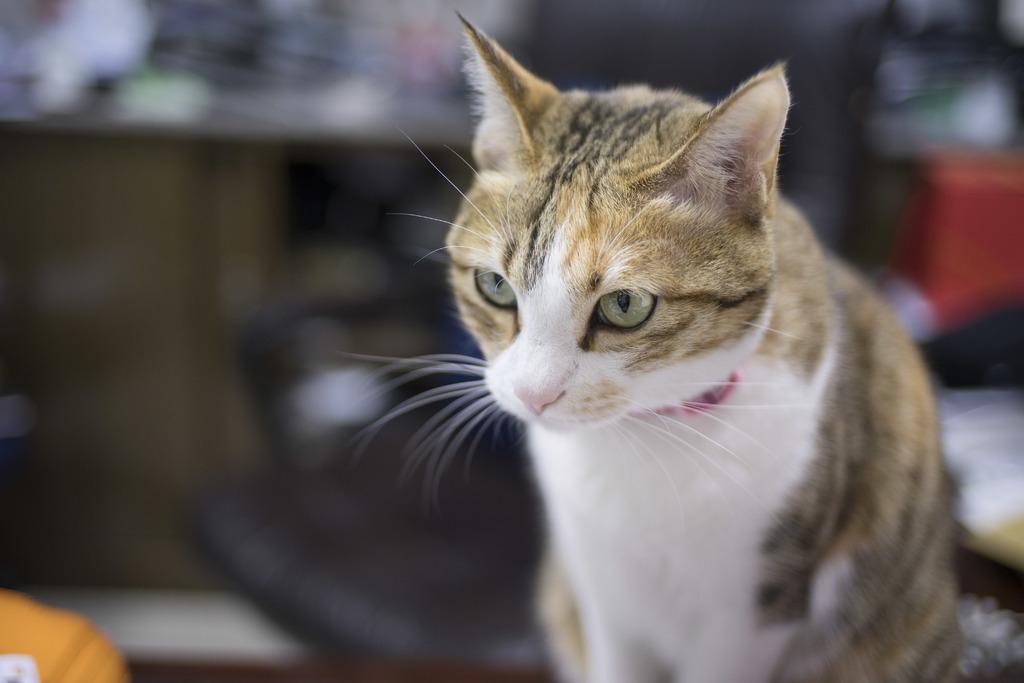Please provide a concise description of this image. Here there is a cat. 